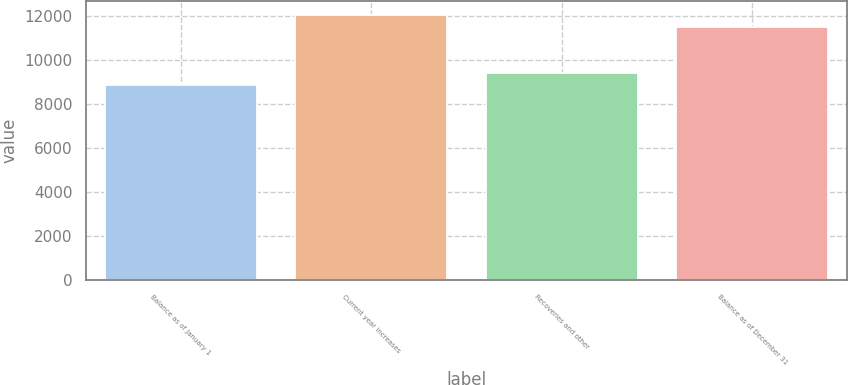Convert chart to OTSL. <chart><loc_0><loc_0><loc_500><loc_500><bar_chart><fcel>Balance as of January 1<fcel>Current year increases<fcel>Recoveries and other<fcel>Balance as of December 31<nl><fcel>8850<fcel>12059<fcel>9427<fcel>11482<nl></chart> 